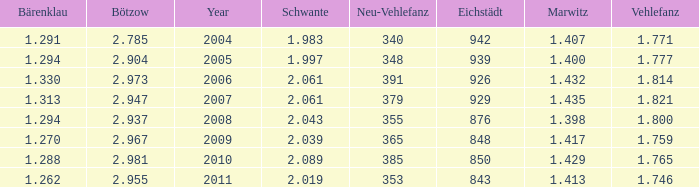What year has a Schwante smaller than 2.043, an Eichstädt smaller than 848, and a Bärenklau smaller than 1.262? 0.0. 